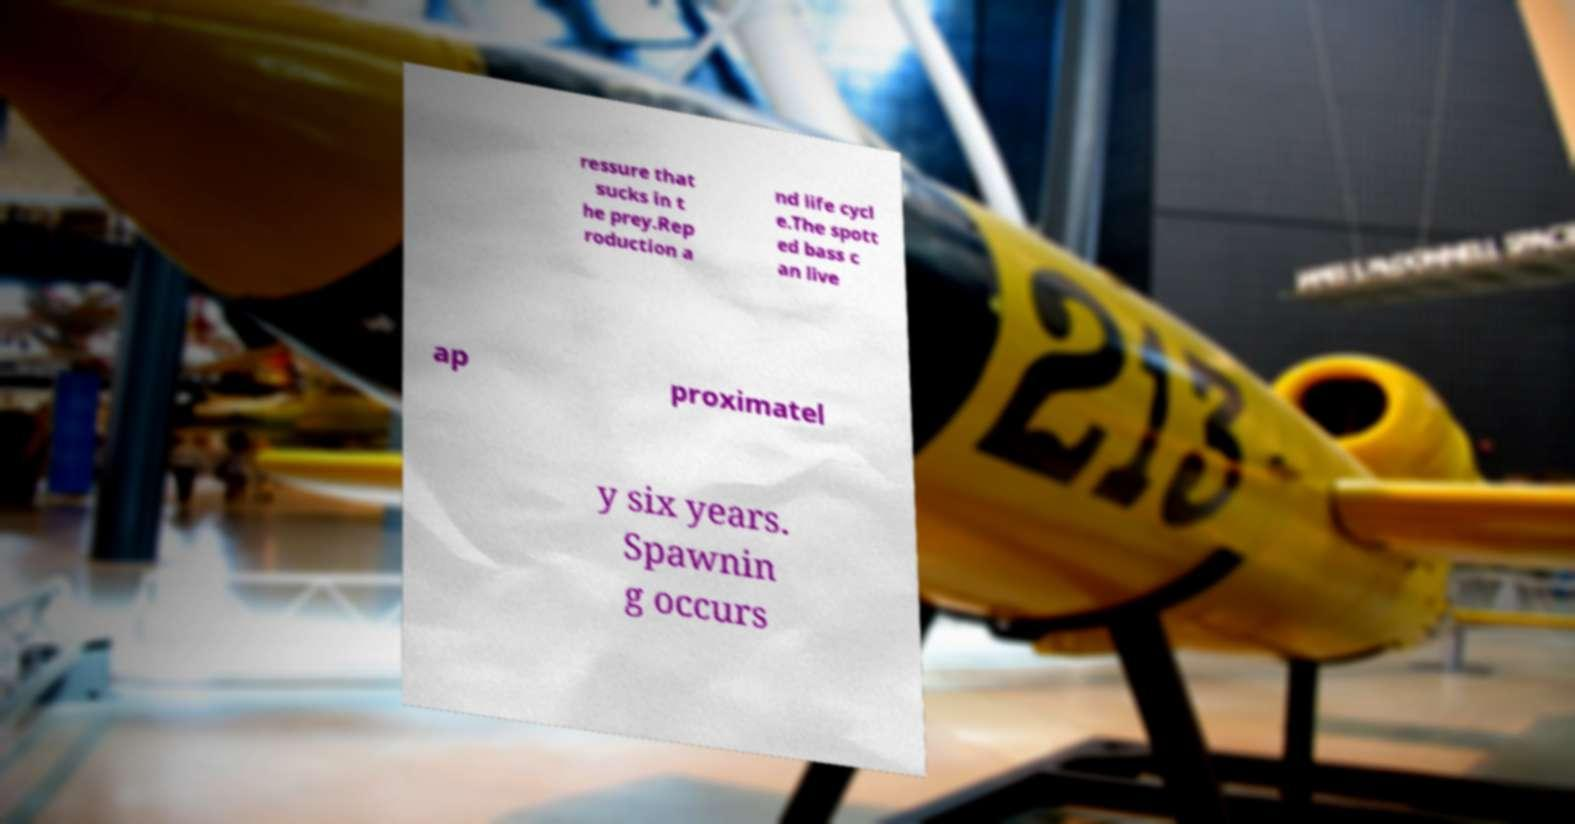Could you extract and type out the text from this image? ressure that sucks in t he prey.Rep roduction a nd life cycl e.The spott ed bass c an live ap proximatel y six years. Spawnin g occurs 